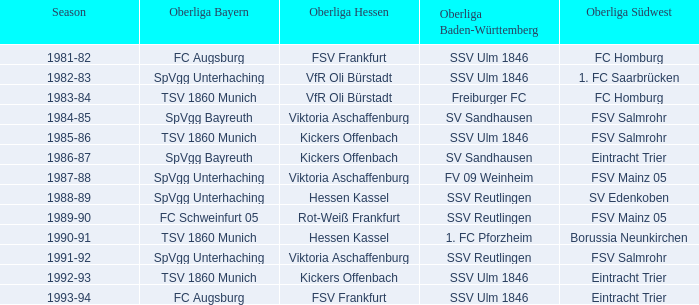During which season did spvgg bayreuth and eintracht trier face each other? 1986-87. 